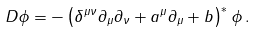Convert formula to latex. <formula><loc_0><loc_0><loc_500><loc_500>D \phi = - \left ( \delta ^ { \mu \nu } \partial _ { \mu } \partial _ { \nu } + a ^ { \mu } \partial _ { \mu } + b \right ) ^ { * } \phi \, .</formula> 